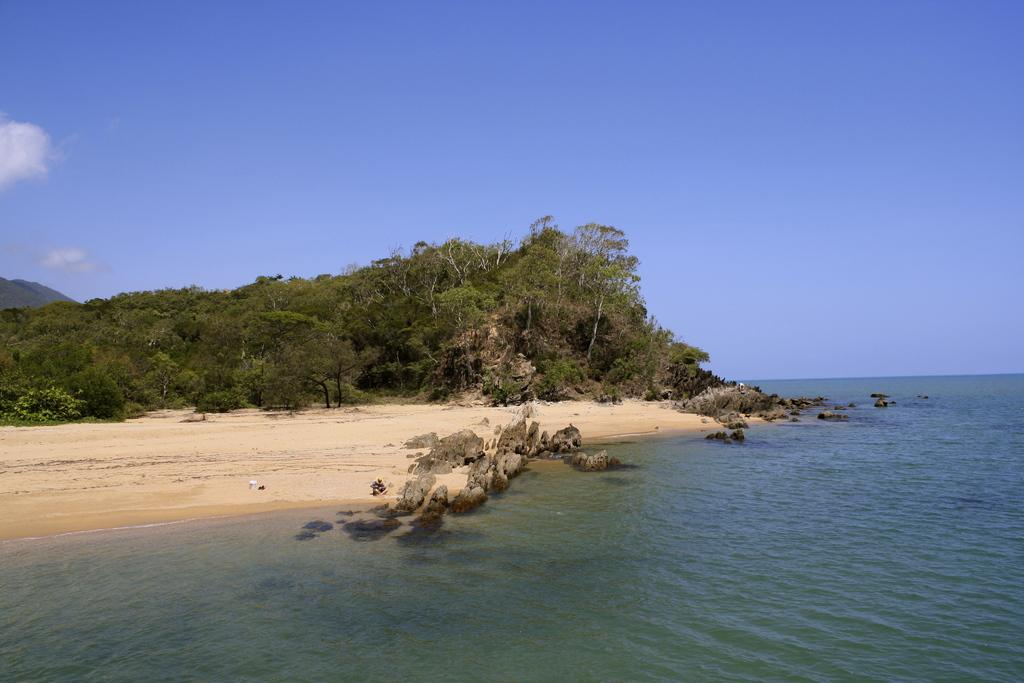What is at the bottom of the image? There is water, rocks, and sand at the bottom of the image. What type of vegetation can be seen in the background of the image? There are trees in the background of the image. What geographical feature is on the left side of the image? There are mountains on the left side of the image. What is visible in the sky in the image? There are clouds in the sky in the image. How does the car grip the rocks in the image? There is no car present in the image, so it is not possible to determine how a car might grip the rocks. 